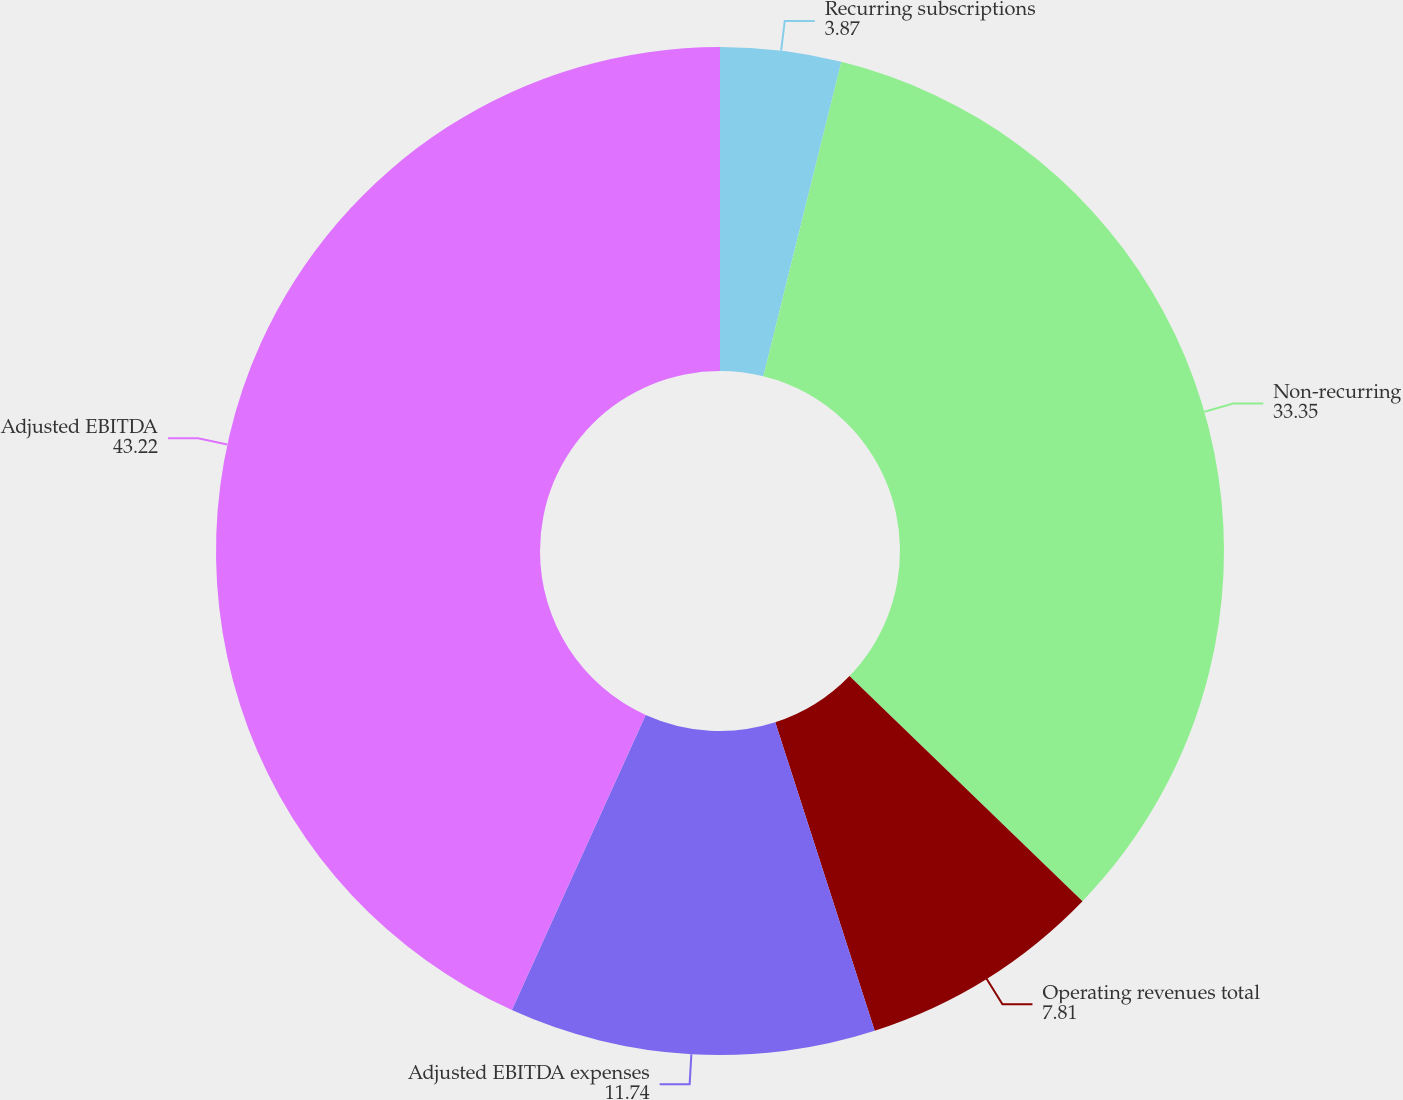<chart> <loc_0><loc_0><loc_500><loc_500><pie_chart><fcel>Recurring subscriptions<fcel>Non-recurring<fcel>Operating revenues total<fcel>Adjusted EBITDA expenses<fcel>Adjusted EBITDA<nl><fcel>3.87%<fcel>33.35%<fcel>7.81%<fcel>11.74%<fcel>43.22%<nl></chart> 